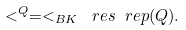Convert formula to latex. <formula><loc_0><loc_0><loc_500><loc_500>< ^ { Q } = < _ { B K } \ r e s \ r e p ( Q ) .</formula> 